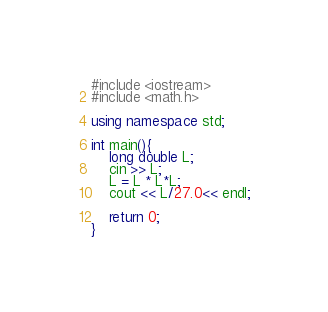<code> <loc_0><loc_0><loc_500><loc_500><_C++_>#include <iostream>
#include <math.h>

using namespace std;

int main(){
	long double L;
	cin >> L;
	L = L * L*L;
	cout << L/27.0<< endl;
	
	return 0;
}
</code> 